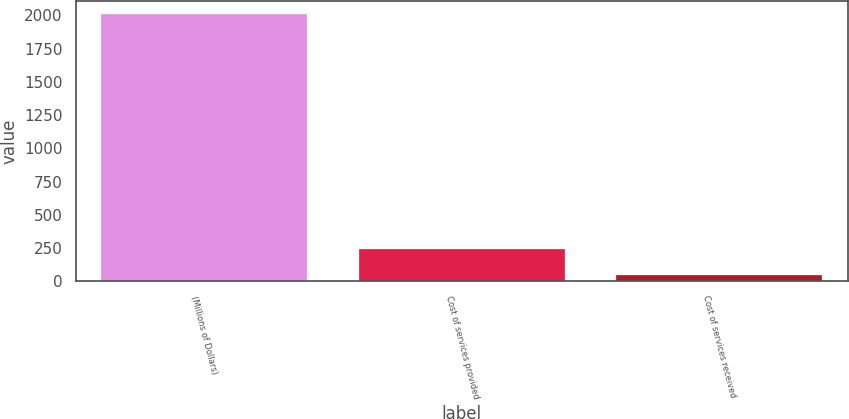Convert chart. <chart><loc_0><loc_0><loc_500><loc_500><bar_chart><fcel>(Millions of Dollars)<fcel>Cost of services provided<fcel>Cost of services received<nl><fcel>2010<fcel>241.5<fcel>45<nl></chart> 